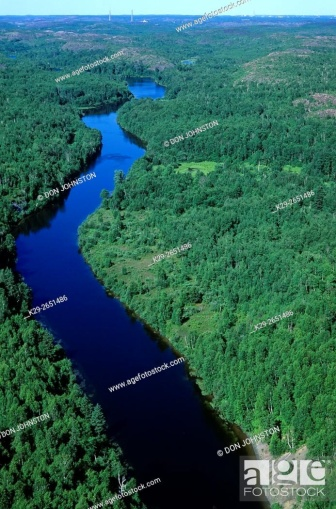Can you describe any signs of animal life in this image? From this altitude and the resolution of the image provided, identifying specific signs of animal life is challenging. No clear animal presence, such as birds in flight or large wildlife near the riverbanks, is visible. However, this type of habitat is typically rich in biodiversity, and we could reasonably infer that a variety of birds, fish, and possibly larger mammals could be present in the area. 